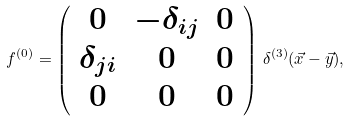<formula> <loc_0><loc_0><loc_500><loc_500>f ^ { ( 0 ) } = \left ( \begin{array} { c c c } 0 & - \delta _ { i j } & 0 \\ \delta _ { j i } & 0 & 0 \\ 0 & 0 & 0 \end{array} \right ) \, \delta ^ { ( 3 ) } ( { \vec { x } } - { \vec { y } } ) ,</formula> 